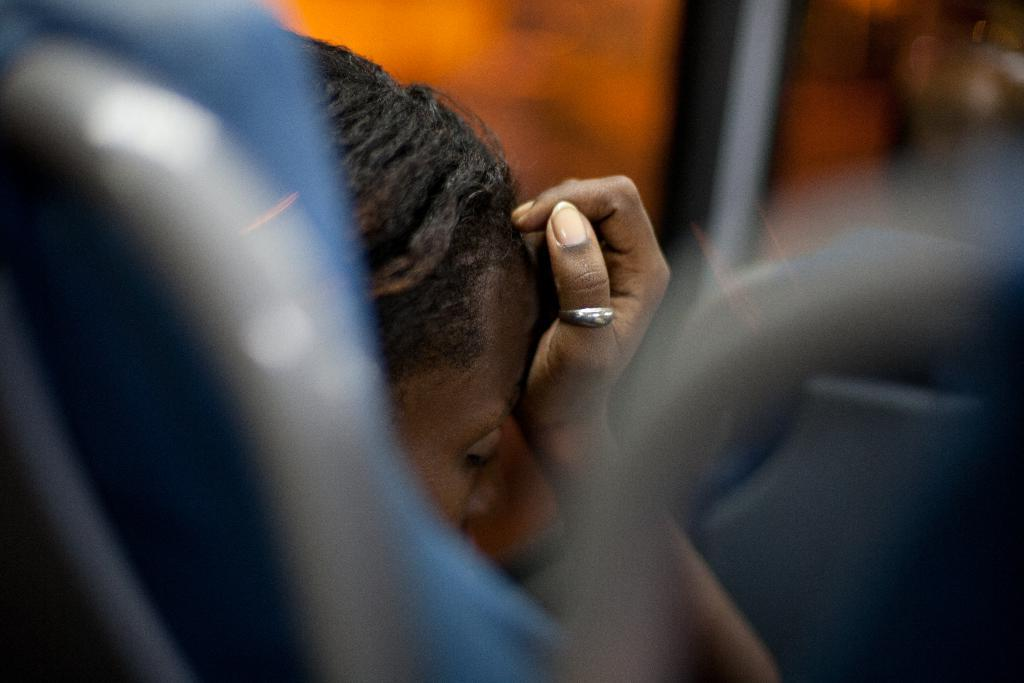What is the person in the image doing? The person is sitting in the image. Can you describe the person's body language or gesture? The person is keeping a hand to their head. What type of sea creature can be seen swimming near the person in the image? There is no sea creature present in the image; it only features a person sitting with a hand to their head. Are there any giants visible in the image? There are no giants present in the image. 